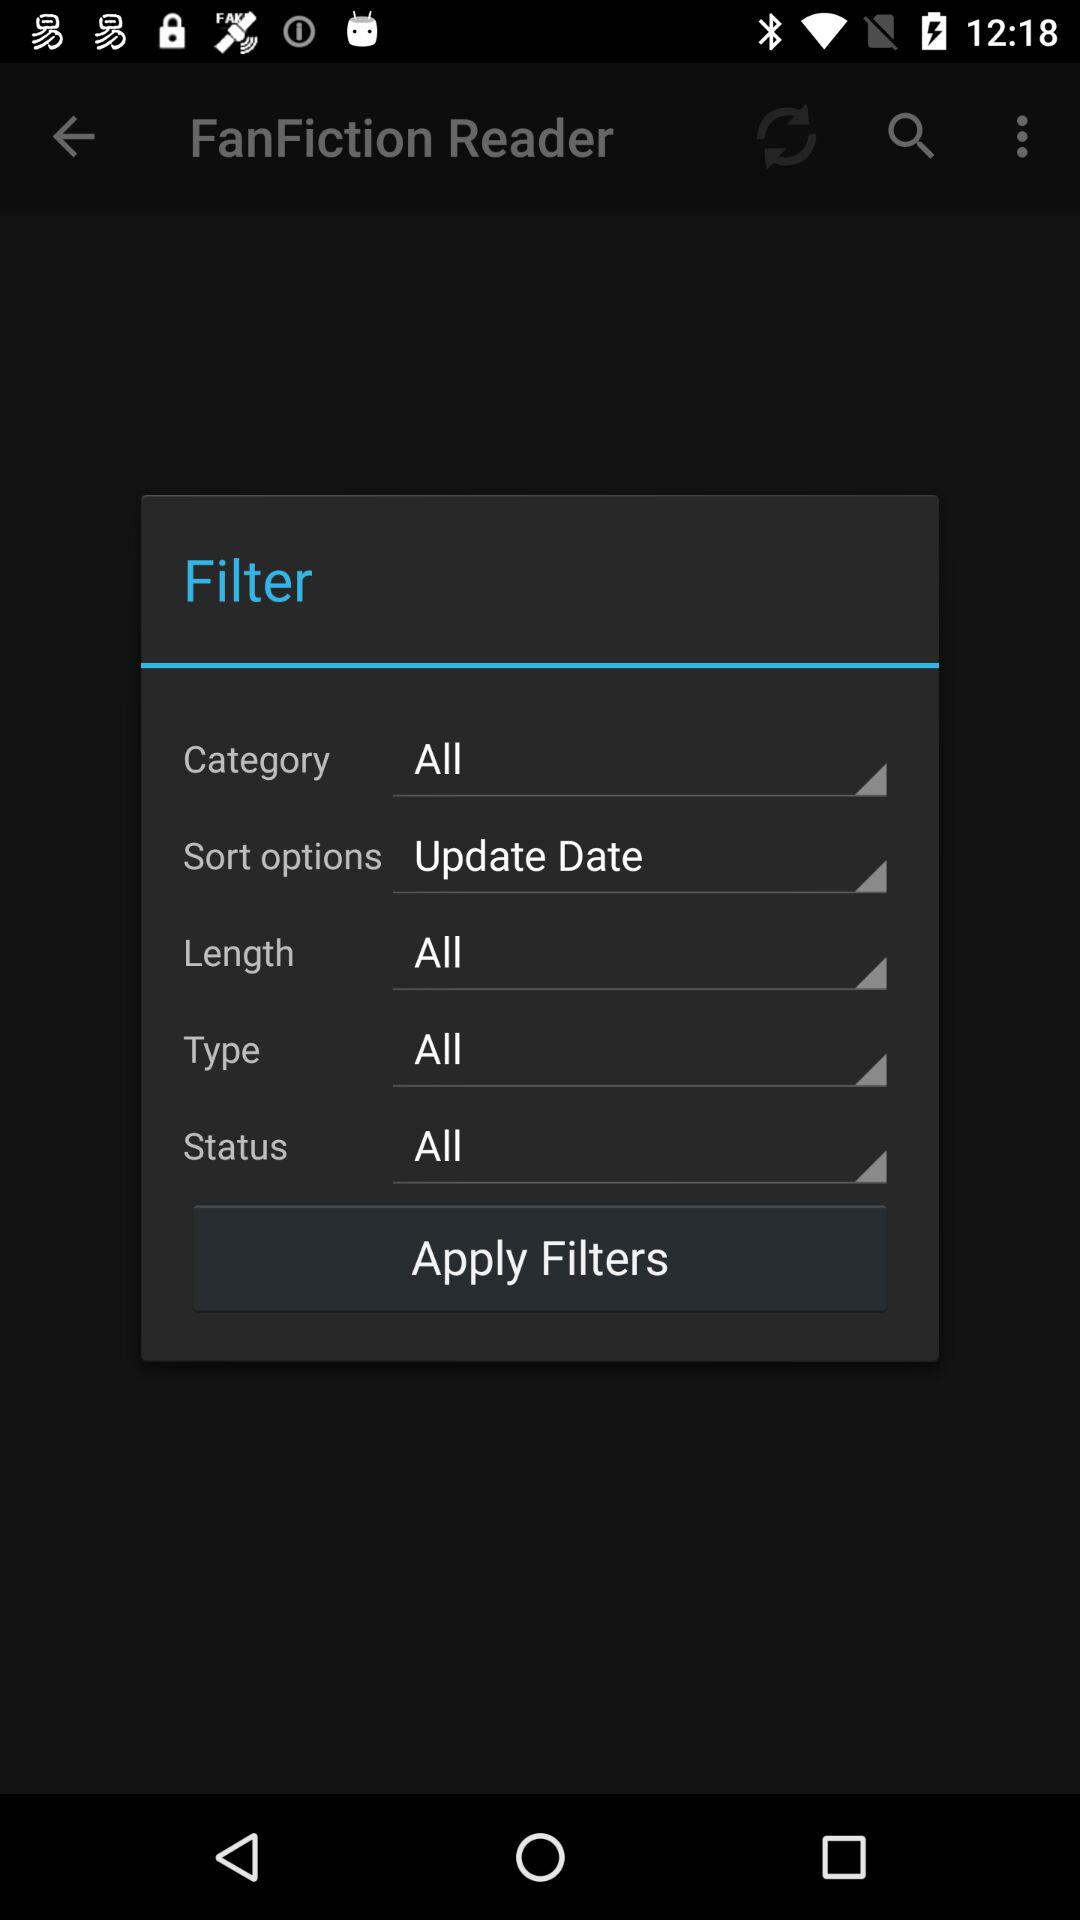How many filters have the label 'All'?
Answer the question using a single word or phrase. 4 